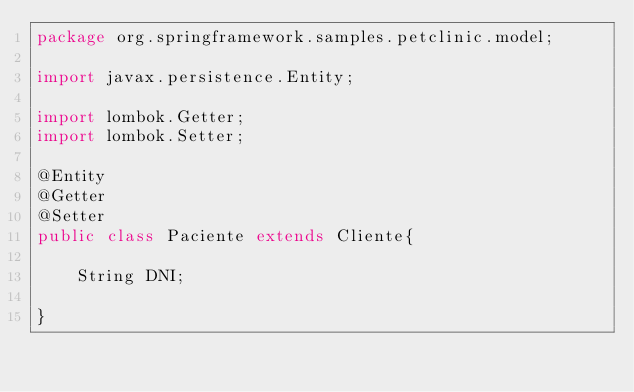<code> <loc_0><loc_0><loc_500><loc_500><_Java_>package org.springframework.samples.petclinic.model;

import javax.persistence.Entity;

import lombok.Getter;
import lombok.Setter;

@Entity
@Getter
@Setter
public class Paciente extends Cliente{

    String DNI;
    
}
</code> 